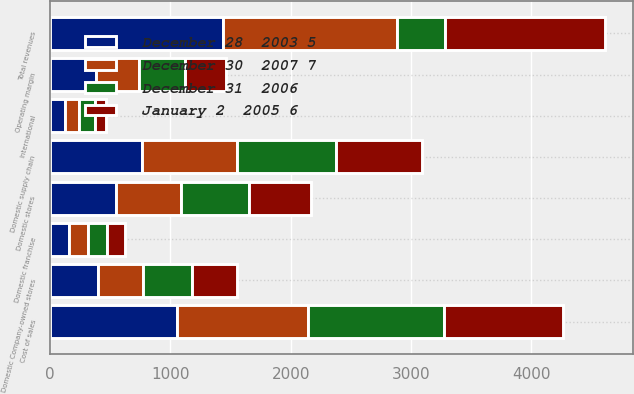<chart> <loc_0><loc_0><loc_500><loc_500><stacked_bar_chart><ecel><fcel>Domestic Company-owned stores<fcel>Domestic franchise<fcel>Domestic stores<fcel>Domestic supply chain<fcel>International<fcel>Total revenues<fcel>Cost of sales<fcel>Operating margin<nl><fcel>January 2  2005 6<fcel>375.4<fcel>144.5<fcel>519.9<fcel>717.1<fcel>96.4<fcel>1333.3<fcel>997.7<fcel>335.6<nl><fcel>December 30  2007 7<fcel>382.5<fcel>155<fcel>537.5<fcel>792<fcel>117<fcel>1446.5<fcel>1092.8<fcel>353.7<nl><fcel>December 31  2006<fcel>401<fcel>161.9<fcel>562.9<fcel>819.1<fcel>129.6<fcel>401<fcel>1126.3<fcel>385.3<nl><fcel>December 28  2003 5<fcel>393.4<fcel>157.7<fcel>551.1<fcel>762.8<fcel>123.4<fcel>1437.3<fcel>1052.8<fcel>384.5<nl></chart> 